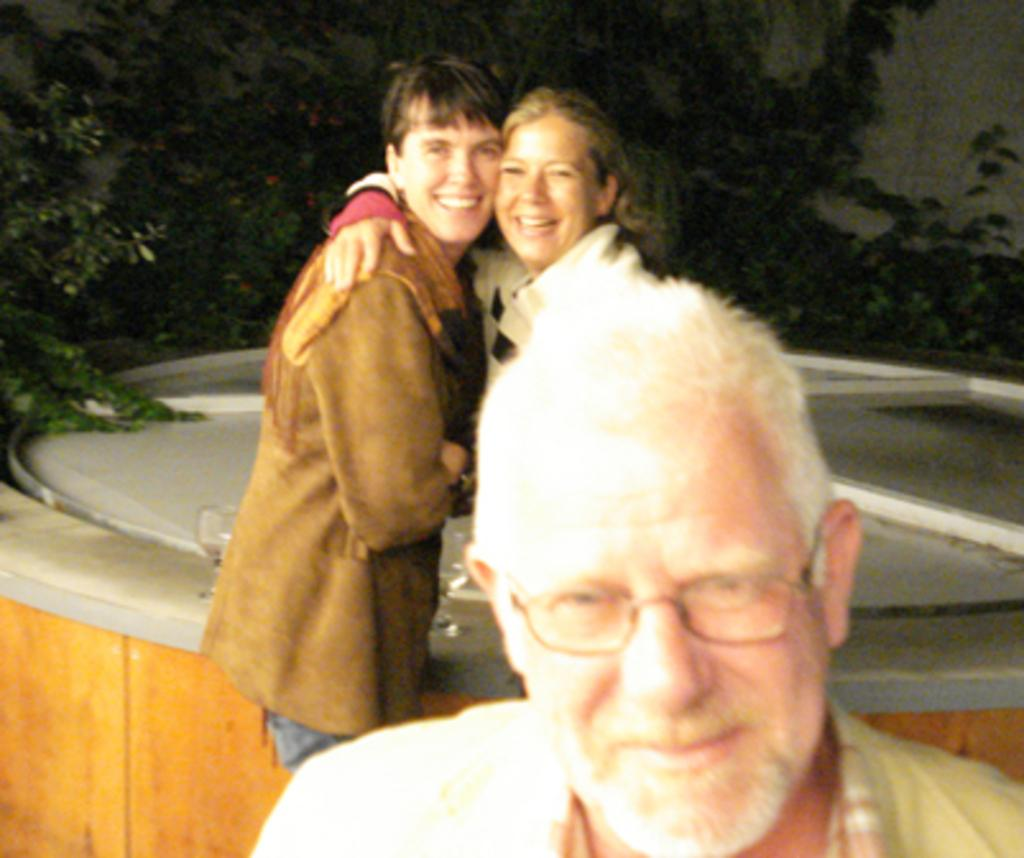Who is the main subject at the bottom of the image? There is a man at the bottom of the image. What can be seen in the background of the image? There is a man and a woman in the background of the image, along with plants and a wall. What are the man and woman doing in the image? The man and woman are standing at an object and smiling. What type of vegetation is visible in the background? There are plants in the background of the image. What caption is written on the image? There is no caption present in the image. How many pizzas are being served in the image? There are no pizzas present in the image. 